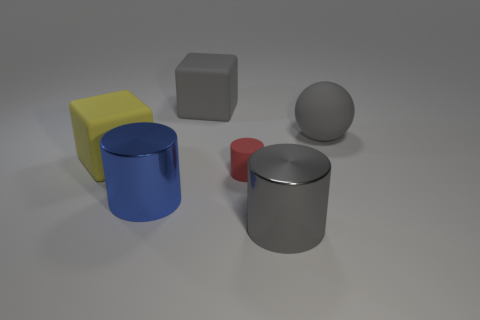Subtract all tiny red cylinders. How many cylinders are left? 2 Subtract all gray cylinders. How many cylinders are left? 2 Subtract all balls. How many objects are left? 5 Add 1 large gray cylinders. How many objects exist? 7 Add 5 small matte cylinders. How many small matte cylinders are left? 6 Add 4 big balls. How many big balls exist? 5 Subtract 0 blue cubes. How many objects are left? 6 Subtract 1 blocks. How many blocks are left? 1 Subtract all red cylinders. Subtract all purple cubes. How many cylinders are left? 2 Subtract all gray balls. How many red cubes are left? 0 